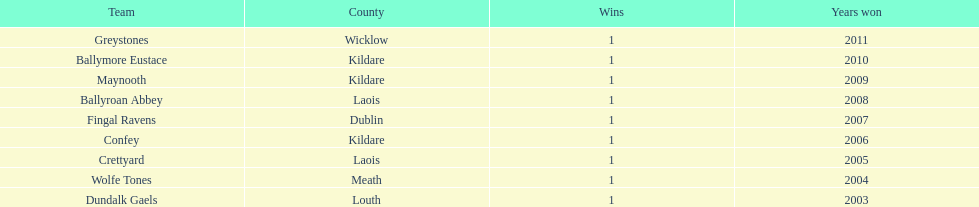What is the final team on the chart? Dundalk Gaels. 